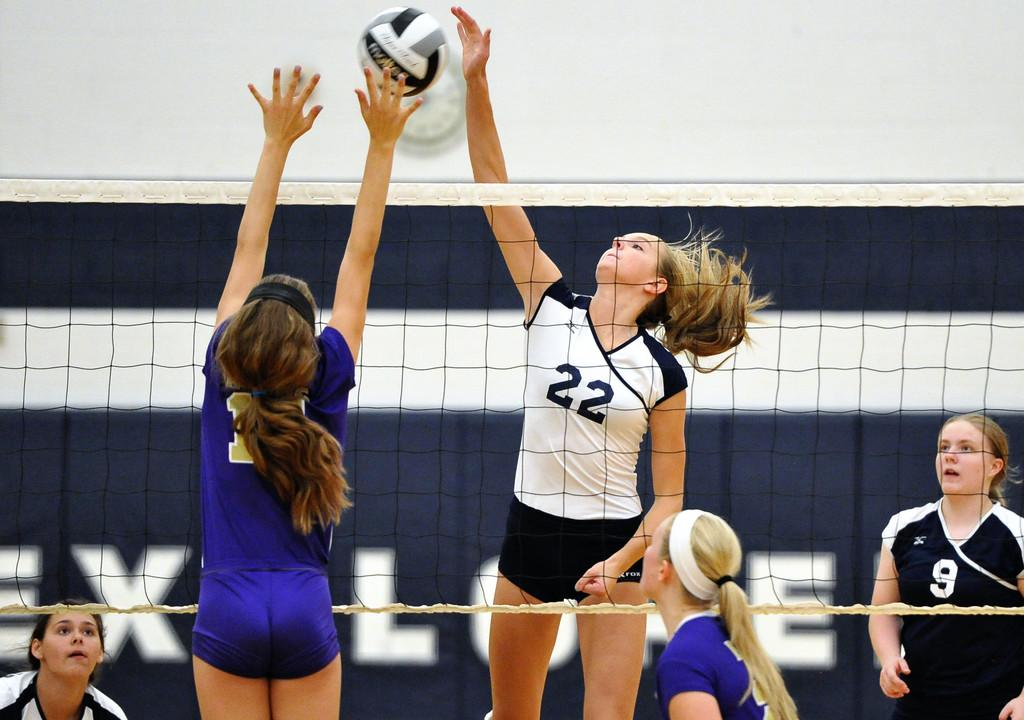<image>
Provide a brief description of the given image. Player number 22 jumps to spike the ball over the outstretched arms of a defender during a volleyball match. 